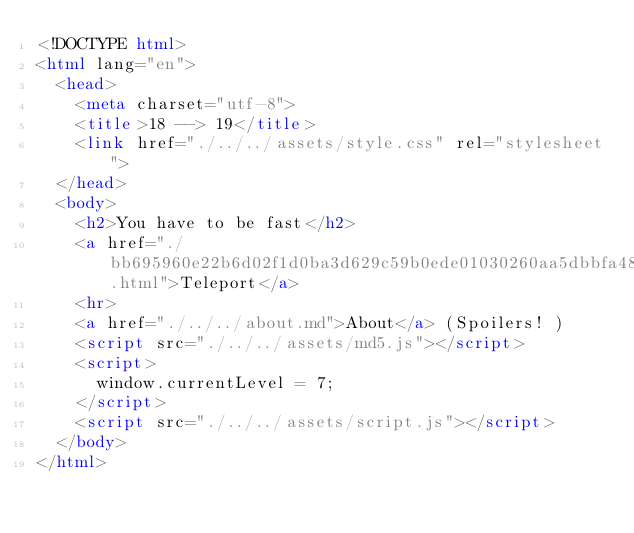<code> <loc_0><loc_0><loc_500><loc_500><_HTML_><!DOCTYPE html>
<html lang="en">
  <head>
    <meta charset="utf-8">
    <title>18 --> 19</title>
    <link href="./../../assets/style.css" rel="stylesheet">
  </head>
  <body>
    <h2>You have to be fast</h2>
    <a href="./bb695960e22b6d02f1d0ba3d629c59b0ede01030260aa5dbbfa4816c90909468.html">Teleport</a>
    <hr>
    <a href="./../../about.md">About</a> (Spoilers! )
    <script src="./../../assets/md5.js"></script>
    <script>
      window.currentLevel = 7;
    </script>
    <script src="./../../assets/script.js"></script>
  </body>
</html></code> 